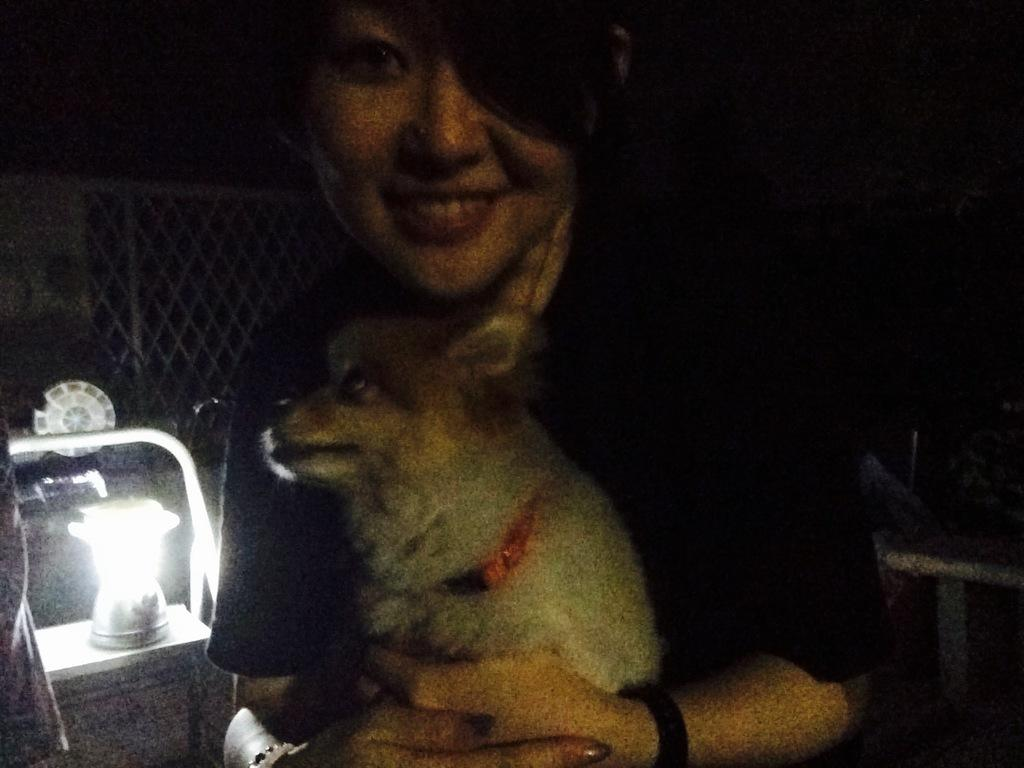Who is present in the image? There is a woman in the image. What is the woman doing in the image? The woman is smiling in the image. What is the woman holding in the image? The woman is holding a puppy in the image. What object can be seen in the image besides the woman and the puppy? There is a lamp in the image. What can be seen in the background of the image? There is a fence in the background of the image. What type of ghost can be seen interacting with the woman in the image? There is no ghost present in the image; it features a woman holding a puppy. What type of crook is visible in the image? There is no crook present in the image; it features a woman holding a puppy, a lamp, and a fence in the background. 